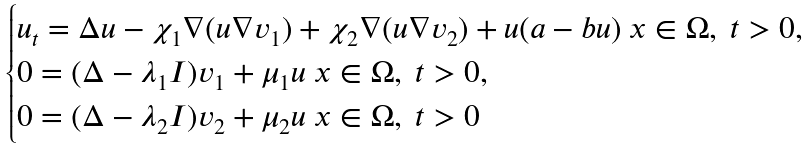<formula> <loc_0><loc_0><loc_500><loc_500>\begin{cases} u _ { t } = \Delta u - \chi _ { 1 } \nabla ( u \nabla v _ { 1 } ) + \chi _ { 2 } \nabla ( u \nabla v _ { 2 } ) + u ( a - b u ) \ x \in \Omega , \ t > 0 , \\ 0 = ( \Delta - \lambda _ { 1 } I ) v _ { 1 } + \mu _ { 1 } u \ x \in \Omega , \ t > 0 , \\ 0 = ( \Delta - \lambda _ { 2 } I ) v _ { 2 } + \mu _ { 2 } u \ x \in \Omega , \ t > 0 \end{cases}</formula> 